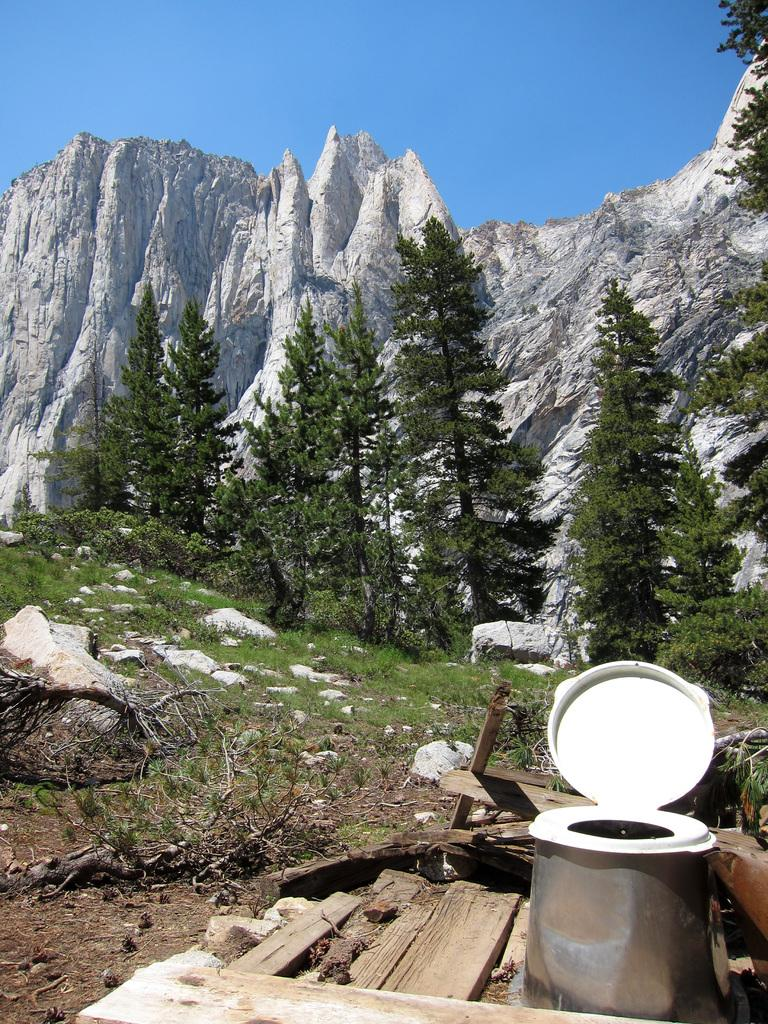What type of furniture is present in the image? There is a commode in the image. What type of vegetation is visible in the image? There is grass in the image. What can be seen in the background of the image? There are trees and a mountain in the background of the image. What part of the natural environment is visible in the image? The sky is visible in the background of the image. How many cows are grazing on the level ground in the image? There are no cows present in the image. What type of bird can be seen perched on the crow of the commode in the image? There is no bird perched on the commode in the image. 